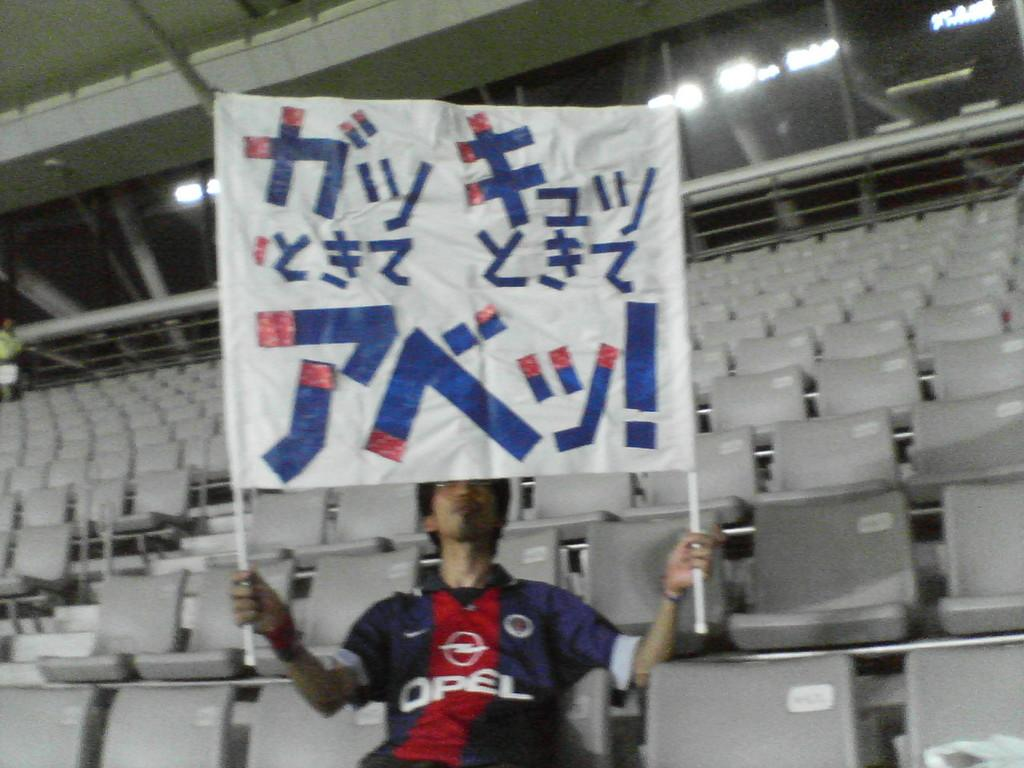<image>
Provide a brief description of the given image. A man wearing a red and blue Opel shirt is sitting in an empty stadium holding up a large sign. 